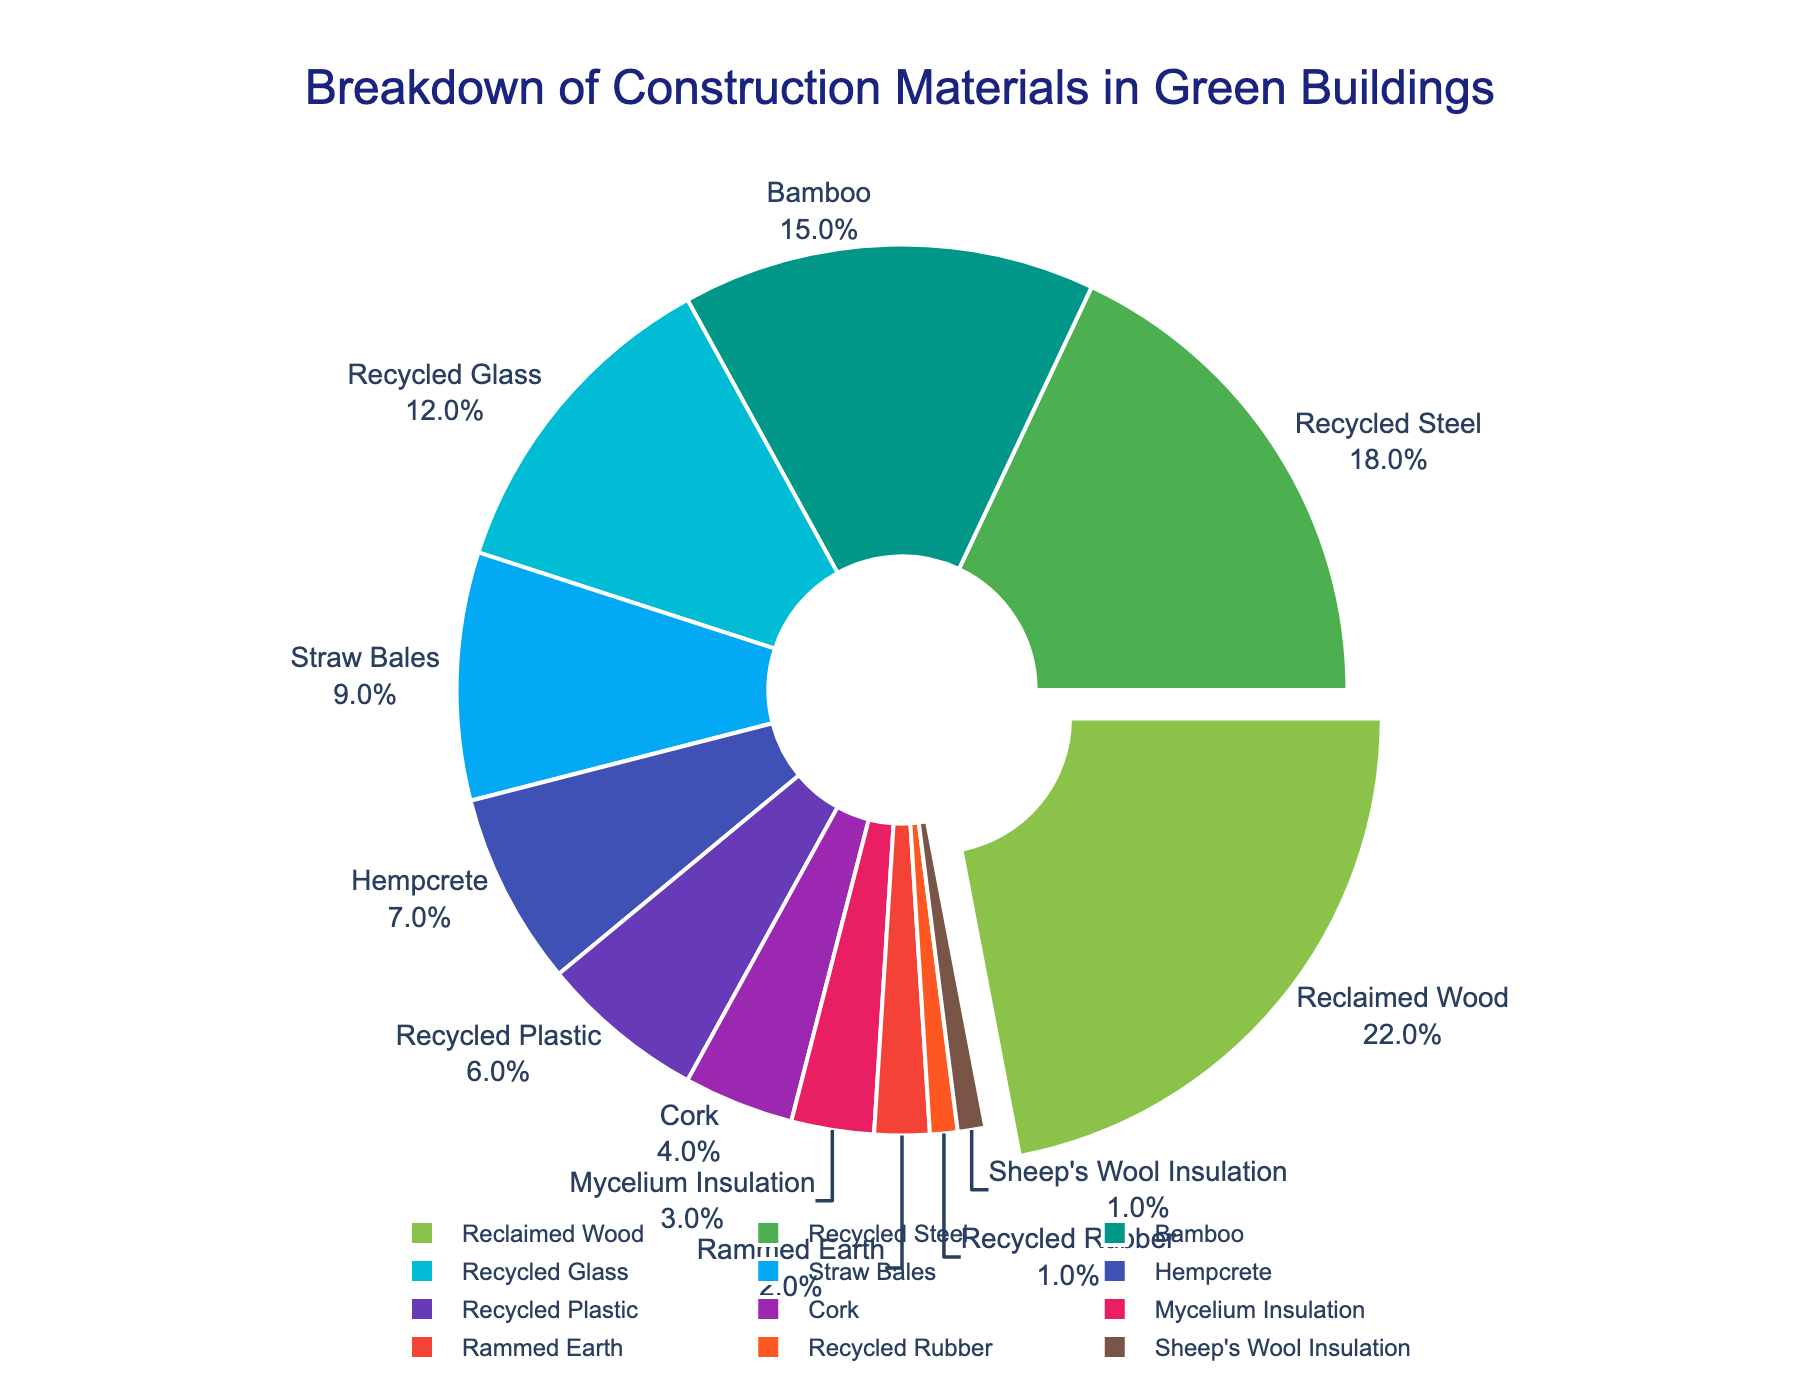What material is used the most in green buildings? The material used the most is represented by the largest section of the pie chart. It is labeled "Reclaimed Wood" with a percentage of 22%.
Answer: Reclaimed Wood Which material has the least usage in green buildings? The smallest section of the pie chart represents the material with the least usage. It is labeled "Sheep's Wool Insulation" and "Recycled Rubber", both with a percentage of 1%.
Answer: Sheep's Wool Insulation, Recycled Rubber What is the combined percentage of Reclaimed Wood and Recycled Steel? Reclaimed Wood has a percentage of 22%, and Recycled Steel has a percentage of 18%. Summing them up: 22% + 18% = 40%
Answer: 40% Which material has a higher percentage, Bamboo or Recycled Glass? By comparing the two sections in the pie chart, Bamboo has a percentage of 15%, whereas Recycled Glass has a percentage of 12%. Bamboo is higher.
Answer: Bamboo What is the difference in percentage between Bamboo and Straw Bales? Bamboo makes up 15% and Straw Bales 9%. The difference is 15% - 9% = 6%
Answer: 6% What materials have percentages greater than 10%? By examining the pie chart, the materials with percentages greater than 10% are Reclaimed Wood (22%), Recycled Steel (18%), Bamboo (15%), and Recycled Glass (12%).
Answer: Reclaimed Wood, Recycled Steel, Bamboo, Recycled Glass What is the percentage sum of all materials with less than 5% usage? The materials with less than 5% usage are Cork (4%), Mycelium Insulation (3%), Rammed Earth (2%), Recycled Rubber (1%), and Sheep's Wool Insulation (1%). Summing these: 4% + 3% + 2% + 1% + 1% = 11%
Answer: 11% Is Hempcrete used more or less than Straw Bales in green buildings? By comparing the sections, Hempcrete has a percentage of 7%, and Straw Bales has 9%. Hempcrete is used less.
Answer: Less What materials are between 5% and 10% in usage? The pie chart shows that the materials between 5% and 10% are Straw Bales (9%), Hempcrete (7%), and Recycled Plastic (6%).
Answer: Straw Bales, Hempcrete, Recycled Plastic 